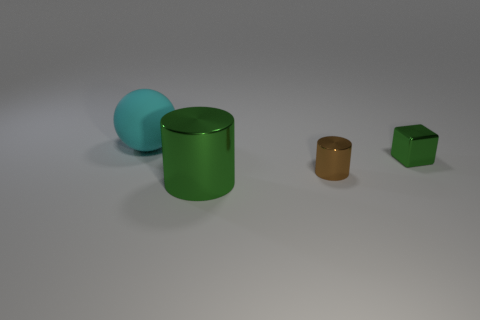Add 1 large objects. How many objects exist? 5 Subtract all blocks. How many objects are left? 3 Add 3 cylinders. How many cylinders are left? 5 Add 2 tiny metallic blocks. How many tiny metallic blocks exist? 3 Subtract 1 brown cylinders. How many objects are left? 3 Subtract all cyan metallic blocks. Subtract all small green metal cubes. How many objects are left? 3 